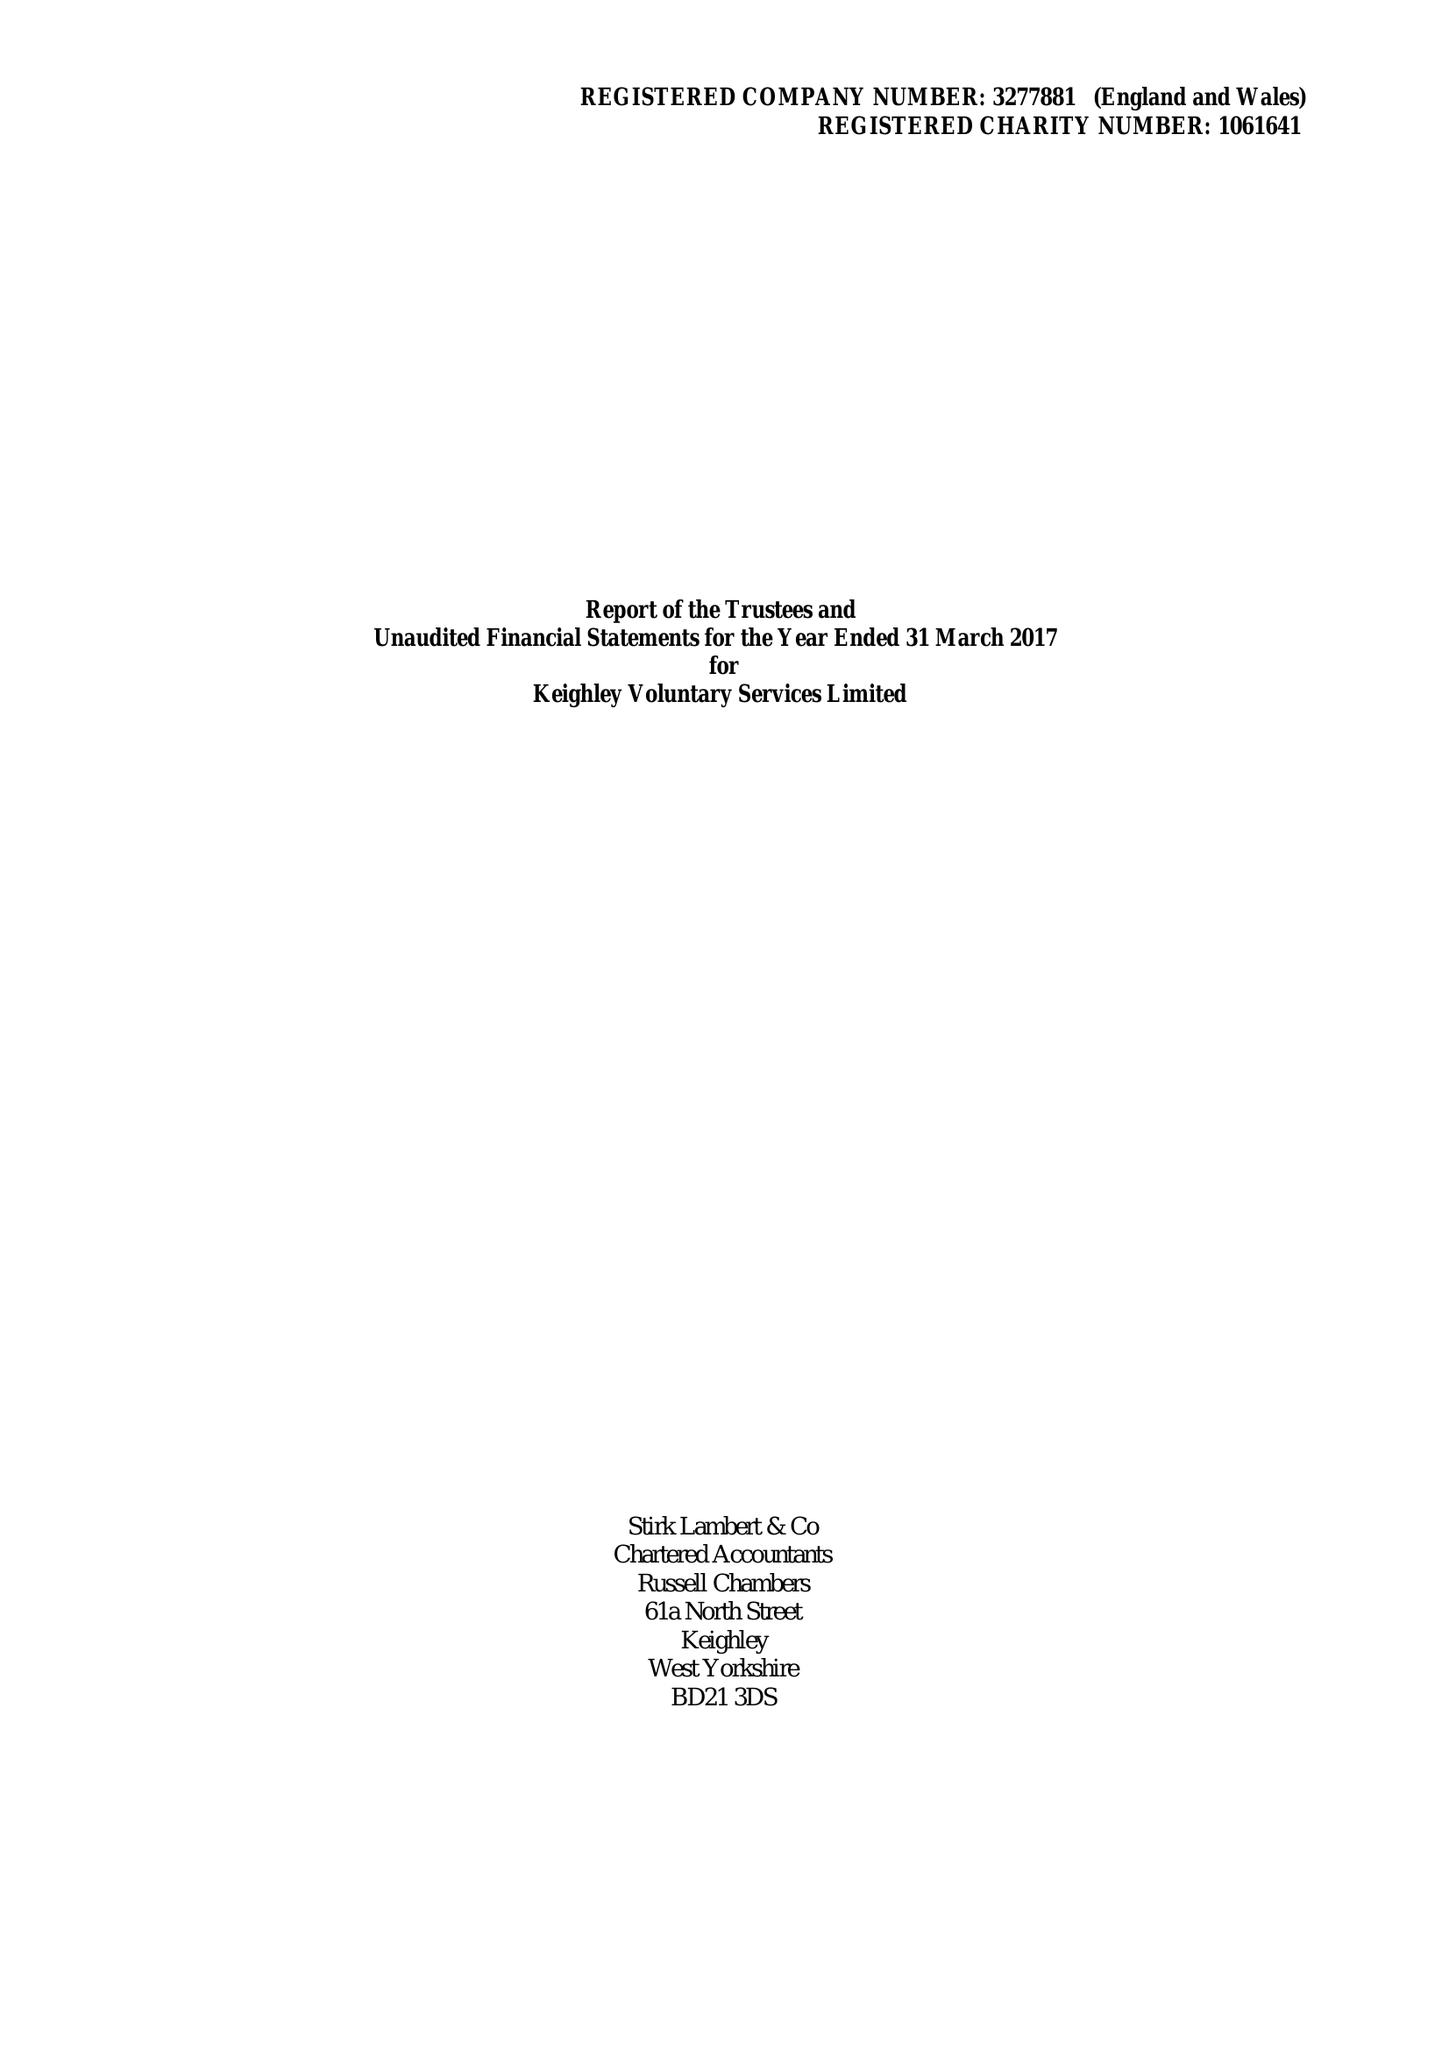What is the value for the charity_number?
Answer the question using a single word or phrase. 1061641 